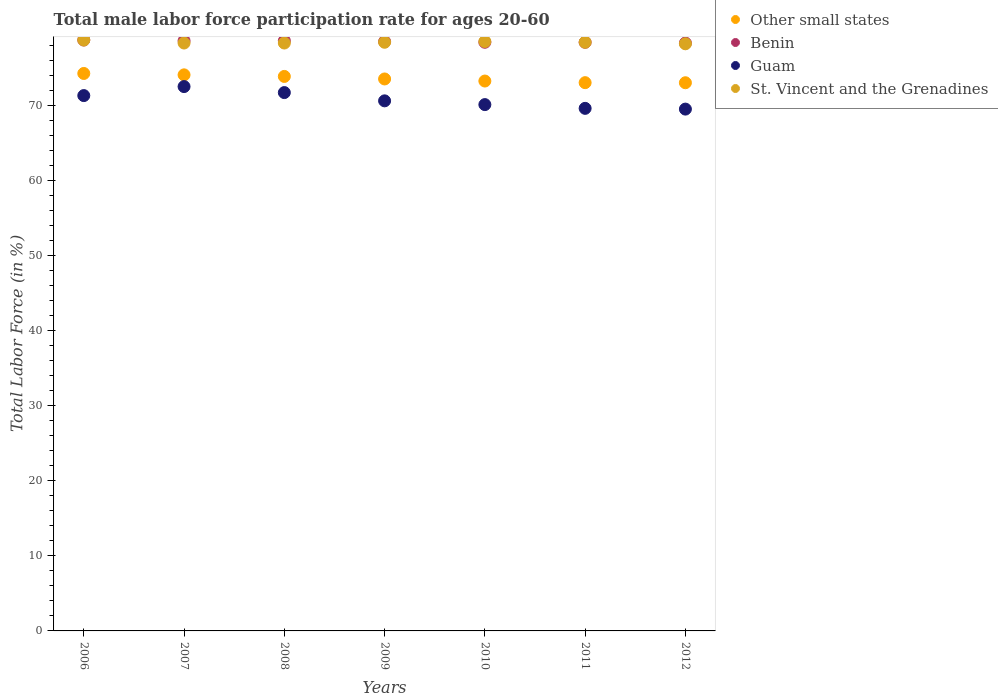How many different coloured dotlines are there?
Give a very brief answer. 4. What is the male labor force participation rate in Other small states in 2011?
Give a very brief answer. 73.02. Across all years, what is the maximum male labor force participation rate in St. Vincent and the Grenadines?
Make the answer very short. 78.7. Across all years, what is the minimum male labor force participation rate in Benin?
Make the answer very short. 78.3. In which year was the male labor force participation rate in St. Vincent and the Grenadines maximum?
Offer a very short reply. 2006. In which year was the male labor force participation rate in Other small states minimum?
Provide a succinct answer. 2012. What is the total male labor force participation rate in Benin in the graph?
Offer a terse response. 549.5. What is the difference between the male labor force participation rate in Other small states in 2008 and that in 2009?
Make the answer very short. 0.34. What is the difference between the male labor force participation rate in Benin in 2008 and the male labor force participation rate in St. Vincent and the Grenadines in 2009?
Make the answer very short. 0.2. What is the average male labor force participation rate in Benin per year?
Ensure brevity in your answer.  78.5. In the year 2008, what is the difference between the male labor force participation rate in Benin and male labor force participation rate in St. Vincent and the Grenadines?
Give a very brief answer. 0.3. In how many years, is the male labor force participation rate in Benin greater than 6 %?
Provide a succinct answer. 7. What is the ratio of the male labor force participation rate in Guam in 2006 to that in 2009?
Keep it short and to the point. 1.01. Is the difference between the male labor force participation rate in Benin in 2009 and 2010 greater than the difference between the male labor force participation rate in St. Vincent and the Grenadines in 2009 and 2010?
Your answer should be compact. Yes. What is the difference between the highest and the second highest male labor force participation rate in Benin?
Provide a succinct answer. 0.1. What is the difference between the highest and the lowest male labor force participation rate in Benin?
Provide a succinct answer. 0.4. In how many years, is the male labor force participation rate in Guam greater than the average male labor force participation rate in Guam taken over all years?
Your answer should be very brief. 3. Is it the case that in every year, the sum of the male labor force participation rate in Benin and male labor force participation rate in St. Vincent and the Grenadines  is greater than the sum of male labor force participation rate in Guam and male labor force participation rate in Other small states?
Your answer should be very brief. No. Is it the case that in every year, the sum of the male labor force participation rate in Other small states and male labor force participation rate in Benin  is greater than the male labor force participation rate in St. Vincent and the Grenadines?
Your response must be concise. Yes. Is the male labor force participation rate in Guam strictly greater than the male labor force participation rate in Benin over the years?
Your response must be concise. No. Is the male labor force participation rate in Benin strictly less than the male labor force participation rate in Other small states over the years?
Give a very brief answer. No. How many years are there in the graph?
Offer a terse response. 7. Does the graph contain grids?
Give a very brief answer. No. What is the title of the graph?
Your answer should be very brief. Total male labor force participation rate for ages 20-60. Does "Micronesia" appear as one of the legend labels in the graph?
Provide a short and direct response. No. What is the Total Labor Force (in %) of Other small states in 2006?
Make the answer very short. 74.25. What is the Total Labor Force (in %) in Benin in 2006?
Keep it short and to the point. 78.7. What is the Total Labor Force (in %) of Guam in 2006?
Provide a succinct answer. 71.3. What is the Total Labor Force (in %) in St. Vincent and the Grenadines in 2006?
Ensure brevity in your answer.  78.7. What is the Total Labor Force (in %) in Other small states in 2007?
Your answer should be very brief. 74.06. What is the Total Labor Force (in %) of Benin in 2007?
Offer a very short reply. 78.6. What is the Total Labor Force (in %) in Guam in 2007?
Give a very brief answer. 72.5. What is the Total Labor Force (in %) of St. Vincent and the Grenadines in 2007?
Ensure brevity in your answer.  78.3. What is the Total Labor Force (in %) of Other small states in 2008?
Offer a very short reply. 73.85. What is the Total Labor Force (in %) of Benin in 2008?
Ensure brevity in your answer.  78.6. What is the Total Labor Force (in %) of Guam in 2008?
Provide a succinct answer. 71.7. What is the Total Labor Force (in %) of St. Vincent and the Grenadines in 2008?
Provide a short and direct response. 78.3. What is the Total Labor Force (in %) of Other small states in 2009?
Keep it short and to the point. 73.51. What is the Total Labor Force (in %) of Benin in 2009?
Provide a succinct answer. 78.5. What is the Total Labor Force (in %) of Guam in 2009?
Ensure brevity in your answer.  70.6. What is the Total Labor Force (in %) of St. Vincent and the Grenadines in 2009?
Keep it short and to the point. 78.4. What is the Total Labor Force (in %) in Other small states in 2010?
Ensure brevity in your answer.  73.24. What is the Total Labor Force (in %) in Benin in 2010?
Provide a short and direct response. 78.4. What is the Total Labor Force (in %) in Guam in 2010?
Make the answer very short. 70.1. What is the Total Labor Force (in %) of St. Vincent and the Grenadines in 2010?
Offer a terse response. 78.5. What is the Total Labor Force (in %) in Other small states in 2011?
Give a very brief answer. 73.02. What is the Total Labor Force (in %) in Benin in 2011?
Keep it short and to the point. 78.4. What is the Total Labor Force (in %) of Guam in 2011?
Your answer should be very brief. 69.6. What is the Total Labor Force (in %) of St. Vincent and the Grenadines in 2011?
Offer a very short reply. 78.4. What is the Total Labor Force (in %) of Other small states in 2012?
Keep it short and to the point. 73.01. What is the Total Labor Force (in %) of Benin in 2012?
Keep it short and to the point. 78.3. What is the Total Labor Force (in %) of Guam in 2012?
Make the answer very short. 69.5. What is the Total Labor Force (in %) in St. Vincent and the Grenadines in 2012?
Keep it short and to the point. 78.2. Across all years, what is the maximum Total Labor Force (in %) in Other small states?
Provide a short and direct response. 74.25. Across all years, what is the maximum Total Labor Force (in %) in Benin?
Keep it short and to the point. 78.7. Across all years, what is the maximum Total Labor Force (in %) in Guam?
Keep it short and to the point. 72.5. Across all years, what is the maximum Total Labor Force (in %) in St. Vincent and the Grenadines?
Make the answer very short. 78.7. Across all years, what is the minimum Total Labor Force (in %) of Other small states?
Offer a very short reply. 73.01. Across all years, what is the minimum Total Labor Force (in %) of Benin?
Your answer should be very brief. 78.3. Across all years, what is the minimum Total Labor Force (in %) in Guam?
Keep it short and to the point. 69.5. Across all years, what is the minimum Total Labor Force (in %) in St. Vincent and the Grenadines?
Your response must be concise. 78.2. What is the total Total Labor Force (in %) in Other small states in the graph?
Ensure brevity in your answer.  514.95. What is the total Total Labor Force (in %) of Benin in the graph?
Offer a very short reply. 549.5. What is the total Total Labor Force (in %) in Guam in the graph?
Ensure brevity in your answer.  495.3. What is the total Total Labor Force (in %) in St. Vincent and the Grenadines in the graph?
Provide a short and direct response. 548.8. What is the difference between the Total Labor Force (in %) in Other small states in 2006 and that in 2007?
Offer a very short reply. 0.19. What is the difference between the Total Labor Force (in %) of Benin in 2006 and that in 2007?
Offer a terse response. 0.1. What is the difference between the Total Labor Force (in %) in Other small states in 2006 and that in 2008?
Make the answer very short. 0.4. What is the difference between the Total Labor Force (in %) in Benin in 2006 and that in 2008?
Offer a very short reply. 0.1. What is the difference between the Total Labor Force (in %) of Guam in 2006 and that in 2008?
Your answer should be very brief. -0.4. What is the difference between the Total Labor Force (in %) of Other small states in 2006 and that in 2009?
Your answer should be very brief. 0.73. What is the difference between the Total Labor Force (in %) in Benin in 2006 and that in 2009?
Your answer should be compact. 0.2. What is the difference between the Total Labor Force (in %) in Guam in 2006 and that in 2009?
Provide a succinct answer. 0.7. What is the difference between the Total Labor Force (in %) in St. Vincent and the Grenadines in 2006 and that in 2009?
Offer a very short reply. 0.3. What is the difference between the Total Labor Force (in %) in Other small states in 2006 and that in 2010?
Your answer should be very brief. 1.01. What is the difference between the Total Labor Force (in %) in St. Vincent and the Grenadines in 2006 and that in 2010?
Keep it short and to the point. 0.2. What is the difference between the Total Labor Force (in %) in Other small states in 2006 and that in 2011?
Give a very brief answer. 1.23. What is the difference between the Total Labor Force (in %) of St. Vincent and the Grenadines in 2006 and that in 2011?
Offer a very short reply. 0.3. What is the difference between the Total Labor Force (in %) in Other small states in 2006 and that in 2012?
Offer a very short reply. 1.24. What is the difference between the Total Labor Force (in %) of Benin in 2006 and that in 2012?
Provide a short and direct response. 0.4. What is the difference between the Total Labor Force (in %) of Other small states in 2007 and that in 2008?
Your response must be concise. 0.21. What is the difference between the Total Labor Force (in %) of Benin in 2007 and that in 2008?
Ensure brevity in your answer.  0. What is the difference between the Total Labor Force (in %) of Other small states in 2007 and that in 2009?
Ensure brevity in your answer.  0.55. What is the difference between the Total Labor Force (in %) of Guam in 2007 and that in 2009?
Keep it short and to the point. 1.9. What is the difference between the Total Labor Force (in %) of St. Vincent and the Grenadines in 2007 and that in 2009?
Offer a terse response. -0.1. What is the difference between the Total Labor Force (in %) of Other small states in 2007 and that in 2010?
Offer a terse response. 0.82. What is the difference between the Total Labor Force (in %) of Benin in 2007 and that in 2010?
Provide a succinct answer. 0.2. What is the difference between the Total Labor Force (in %) of St. Vincent and the Grenadines in 2007 and that in 2010?
Keep it short and to the point. -0.2. What is the difference between the Total Labor Force (in %) of Other small states in 2007 and that in 2011?
Ensure brevity in your answer.  1.04. What is the difference between the Total Labor Force (in %) in Benin in 2007 and that in 2011?
Offer a very short reply. 0.2. What is the difference between the Total Labor Force (in %) in Other small states in 2007 and that in 2012?
Offer a very short reply. 1.05. What is the difference between the Total Labor Force (in %) in Benin in 2007 and that in 2012?
Your answer should be compact. 0.3. What is the difference between the Total Labor Force (in %) in Guam in 2007 and that in 2012?
Give a very brief answer. 3. What is the difference between the Total Labor Force (in %) of St. Vincent and the Grenadines in 2007 and that in 2012?
Provide a succinct answer. 0.1. What is the difference between the Total Labor Force (in %) of Other small states in 2008 and that in 2009?
Provide a succinct answer. 0.34. What is the difference between the Total Labor Force (in %) of Benin in 2008 and that in 2009?
Your answer should be very brief. 0.1. What is the difference between the Total Labor Force (in %) in Other small states in 2008 and that in 2010?
Provide a succinct answer. 0.61. What is the difference between the Total Labor Force (in %) of Benin in 2008 and that in 2010?
Your response must be concise. 0.2. What is the difference between the Total Labor Force (in %) of Other small states in 2008 and that in 2011?
Your answer should be compact. 0.83. What is the difference between the Total Labor Force (in %) of Guam in 2008 and that in 2011?
Keep it short and to the point. 2.1. What is the difference between the Total Labor Force (in %) in Other small states in 2008 and that in 2012?
Your answer should be very brief. 0.84. What is the difference between the Total Labor Force (in %) of Benin in 2008 and that in 2012?
Offer a terse response. 0.3. What is the difference between the Total Labor Force (in %) of St. Vincent and the Grenadines in 2008 and that in 2012?
Your response must be concise. 0.1. What is the difference between the Total Labor Force (in %) in Other small states in 2009 and that in 2010?
Your answer should be compact. 0.28. What is the difference between the Total Labor Force (in %) in Benin in 2009 and that in 2010?
Offer a terse response. 0.1. What is the difference between the Total Labor Force (in %) in Guam in 2009 and that in 2010?
Offer a terse response. 0.5. What is the difference between the Total Labor Force (in %) of St. Vincent and the Grenadines in 2009 and that in 2010?
Ensure brevity in your answer.  -0.1. What is the difference between the Total Labor Force (in %) in Other small states in 2009 and that in 2011?
Provide a short and direct response. 0.49. What is the difference between the Total Labor Force (in %) of Benin in 2009 and that in 2011?
Your response must be concise. 0.1. What is the difference between the Total Labor Force (in %) in Guam in 2009 and that in 2011?
Make the answer very short. 1. What is the difference between the Total Labor Force (in %) of Other small states in 2009 and that in 2012?
Make the answer very short. 0.5. What is the difference between the Total Labor Force (in %) of Guam in 2009 and that in 2012?
Offer a terse response. 1.1. What is the difference between the Total Labor Force (in %) in St. Vincent and the Grenadines in 2009 and that in 2012?
Your response must be concise. 0.2. What is the difference between the Total Labor Force (in %) in Other small states in 2010 and that in 2011?
Make the answer very short. 0.22. What is the difference between the Total Labor Force (in %) of Benin in 2010 and that in 2011?
Offer a very short reply. 0. What is the difference between the Total Labor Force (in %) of Guam in 2010 and that in 2011?
Provide a succinct answer. 0.5. What is the difference between the Total Labor Force (in %) in St. Vincent and the Grenadines in 2010 and that in 2011?
Provide a short and direct response. 0.1. What is the difference between the Total Labor Force (in %) of Other small states in 2010 and that in 2012?
Ensure brevity in your answer.  0.23. What is the difference between the Total Labor Force (in %) in Guam in 2010 and that in 2012?
Your answer should be very brief. 0.6. What is the difference between the Total Labor Force (in %) of Other small states in 2011 and that in 2012?
Ensure brevity in your answer.  0.01. What is the difference between the Total Labor Force (in %) in Benin in 2011 and that in 2012?
Offer a very short reply. 0.1. What is the difference between the Total Labor Force (in %) of Other small states in 2006 and the Total Labor Force (in %) of Benin in 2007?
Your answer should be very brief. -4.35. What is the difference between the Total Labor Force (in %) in Other small states in 2006 and the Total Labor Force (in %) in Guam in 2007?
Give a very brief answer. 1.75. What is the difference between the Total Labor Force (in %) of Other small states in 2006 and the Total Labor Force (in %) of St. Vincent and the Grenadines in 2007?
Provide a succinct answer. -4.05. What is the difference between the Total Labor Force (in %) of Guam in 2006 and the Total Labor Force (in %) of St. Vincent and the Grenadines in 2007?
Offer a terse response. -7. What is the difference between the Total Labor Force (in %) of Other small states in 2006 and the Total Labor Force (in %) of Benin in 2008?
Ensure brevity in your answer.  -4.35. What is the difference between the Total Labor Force (in %) in Other small states in 2006 and the Total Labor Force (in %) in Guam in 2008?
Your answer should be compact. 2.55. What is the difference between the Total Labor Force (in %) of Other small states in 2006 and the Total Labor Force (in %) of St. Vincent and the Grenadines in 2008?
Provide a short and direct response. -4.05. What is the difference between the Total Labor Force (in %) of Benin in 2006 and the Total Labor Force (in %) of St. Vincent and the Grenadines in 2008?
Your answer should be very brief. 0.4. What is the difference between the Total Labor Force (in %) of Guam in 2006 and the Total Labor Force (in %) of St. Vincent and the Grenadines in 2008?
Offer a very short reply. -7. What is the difference between the Total Labor Force (in %) in Other small states in 2006 and the Total Labor Force (in %) in Benin in 2009?
Offer a very short reply. -4.25. What is the difference between the Total Labor Force (in %) of Other small states in 2006 and the Total Labor Force (in %) of Guam in 2009?
Ensure brevity in your answer.  3.65. What is the difference between the Total Labor Force (in %) in Other small states in 2006 and the Total Labor Force (in %) in St. Vincent and the Grenadines in 2009?
Your answer should be compact. -4.15. What is the difference between the Total Labor Force (in %) in Benin in 2006 and the Total Labor Force (in %) in St. Vincent and the Grenadines in 2009?
Offer a very short reply. 0.3. What is the difference between the Total Labor Force (in %) of Guam in 2006 and the Total Labor Force (in %) of St. Vincent and the Grenadines in 2009?
Provide a succinct answer. -7.1. What is the difference between the Total Labor Force (in %) of Other small states in 2006 and the Total Labor Force (in %) of Benin in 2010?
Keep it short and to the point. -4.15. What is the difference between the Total Labor Force (in %) of Other small states in 2006 and the Total Labor Force (in %) of Guam in 2010?
Provide a succinct answer. 4.15. What is the difference between the Total Labor Force (in %) in Other small states in 2006 and the Total Labor Force (in %) in St. Vincent and the Grenadines in 2010?
Your answer should be very brief. -4.25. What is the difference between the Total Labor Force (in %) of Benin in 2006 and the Total Labor Force (in %) of St. Vincent and the Grenadines in 2010?
Your answer should be compact. 0.2. What is the difference between the Total Labor Force (in %) of Guam in 2006 and the Total Labor Force (in %) of St. Vincent and the Grenadines in 2010?
Give a very brief answer. -7.2. What is the difference between the Total Labor Force (in %) in Other small states in 2006 and the Total Labor Force (in %) in Benin in 2011?
Your answer should be compact. -4.15. What is the difference between the Total Labor Force (in %) of Other small states in 2006 and the Total Labor Force (in %) of Guam in 2011?
Keep it short and to the point. 4.65. What is the difference between the Total Labor Force (in %) of Other small states in 2006 and the Total Labor Force (in %) of St. Vincent and the Grenadines in 2011?
Your answer should be compact. -4.15. What is the difference between the Total Labor Force (in %) of Benin in 2006 and the Total Labor Force (in %) of Guam in 2011?
Offer a very short reply. 9.1. What is the difference between the Total Labor Force (in %) in Benin in 2006 and the Total Labor Force (in %) in St. Vincent and the Grenadines in 2011?
Offer a very short reply. 0.3. What is the difference between the Total Labor Force (in %) in Other small states in 2006 and the Total Labor Force (in %) in Benin in 2012?
Offer a terse response. -4.05. What is the difference between the Total Labor Force (in %) of Other small states in 2006 and the Total Labor Force (in %) of Guam in 2012?
Give a very brief answer. 4.75. What is the difference between the Total Labor Force (in %) of Other small states in 2006 and the Total Labor Force (in %) of St. Vincent and the Grenadines in 2012?
Keep it short and to the point. -3.95. What is the difference between the Total Labor Force (in %) in Benin in 2006 and the Total Labor Force (in %) in St. Vincent and the Grenadines in 2012?
Provide a short and direct response. 0.5. What is the difference between the Total Labor Force (in %) in Other small states in 2007 and the Total Labor Force (in %) in Benin in 2008?
Provide a short and direct response. -4.54. What is the difference between the Total Labor Force (in %) in Other small states in 2007 and the Total Labor Force (in %) in Guam in 2008?
Keep it short and to the point. 2.36. What is the difference between the Total Labor Force (in %) of Other small states in 2007 and the Total Labor Force (in %) of St. Vincent and the Grenadines in 2008?
Give a very brief answer. -4.24. What is the difference between the Total Labor Force (in %) of Guam in 2007 and the Total Labor Force (in %) of St. Vincent and the Grenadines in 2008?
Make the answer very short. -5.8. What is the difference between the Total Labor Force (in %) of Other small states in 2007 and the Total Labor Force (in %) of Benin in 2009?
Ensure brevity in your answer.  -4.44. What is the difference between the Total Labor Force (in %) of Other small states in 2007 and the Total Labor Force (in %) of Guam in 2009?
Make the answer very short. 3.46. What is the difference between the Total Labor Force (in %) in Other small states in 2007 and the Total Labor Force (in %) in St. Vincent and the Grenadines in 2009?
Keep it short and to the point. -4.34. What is the difference between the Total Labor Force (in %) of Benin in 2007 and the Total Labor Force (in %) of Guam in 2009?
Make the answer very short. 8. What is the difference between the Total Labor Force (in %) in Benin in 2007 and the Total Labor Force (in %) in St. Vincent and the Grenadines in 2009?
Your answer should be compact. 0.2. What is the difference between the Total Labor Force (in %) of Guam in 2007 and the Total Labor Force (in %) of St. Vincent and the Grenadines in 2009?
Make the answer very short. -5.9. What is the difference between the Total Labor Force (in %) in Other small states in 2007 and the Total Labor Force (in %) in Benin in 2010?
Your answer should be compact. -4.34. What is the difference between the Total Labor Force (in %) in Other small states in 2007 and the Total Labor Force (in %) in Guam in 2010?
Give a very brief answer. 3.96. What is the difference between the Total Labor Force (in %) in Other small states in 2007 and the Total Labor Force (in %) in St. Vincent and the Grenadines in 2010?
Your response must be concise. -4.44. What is the difference between the Total Labor Force (in %) in Benin in 2007 and the Total Labor Force (in %) in Guam in 2010?
Give a very brief answer. 8.5. What is the difference between the Total Labor Force (in %) of Other small states in 2007 and the Total Labor Force (in %) of Benin in 2011?
Ensure brevity in your answer.  -4.34. What is the difference between the Total Labor Force (in %) of Other small states in 2007 and the Total Labor Force (in %) of Guam in 2011?
Give a very brief answer. 4.46. What is the difference between the Total Labor Force (in %) in Other small states in 2007 and the Total Labor Force (in %) in St. Vincent and the Grenadines in 2011?
Make the answer very short. -4.34. What is the difference between the Total Labor Force (in %) of Other small states in 2007 and the Total Labor Force (in %) of Benin in 2012?
Make the answer very short. -4.24. What is the difference between the Total Labor Force (in %) of Other small states in 2007 and the Total Labor Force (in %) of Guam in 2012?
Give a very brief answer. 4.56. What is the difference between the Total Labor Force (in %) in Other small states in 2007 and the Total Labor Force (in %) in St. Vincent and the Grenadines in 2012?
Keep it short and to the point. -4.14. What is the difference between the Total Labor Force (in %) of Benin in 2007 and the Total Labor Force (in %) of Guam in 2012?
Your answer should be very brief. 9.1. What is the difference between the Total Labor Force (in %) of Guam in 2007 and the Total Labor Force (in %) of St. Vincent and the Grenadines in 2012?
Keep it short and to the point. -5.7. What is the difference between the Total Labor Force (in %) of Other small states in 2008 and the Total Labor Force (in %) of Benin in 2009?
Provide a short and direct response. -4.65. What is the difference between the Total Labor Force (in %) in Other small states in 2008 and the Total Labor Force (in %) in Guam in 2009?
Provide a short and direct response. 3.25. What is the difference between the Total Labor Force (in %) in Other small states in 2008 and the Total Labor Force (in %) in St. Vincent and the Grenadines in 2009?
Offer a very short reply. -4.55. What is the difference between the Total Labor Force (in %) in Benin in 2008 and the Total Labor Force (in %) in Guam in 2009?
Your answer should be very brief. 8. What is the difference between the Total Labor Force (in %) of Benin in 2008 and the Total Labor Force (in %) of St. Vincent and the Grenadines in 2009?
Provide a short and direct response. 0.2. What is the difference between the Total Labor Force (in %) of Other small states in 2008 and the Total Labor Force (in %) of Benin in 2010?
Your response must be concise. -4.55. What is the difference between the Total Labor Force (in %) of Other small states in 2008 and the Total Labor Force (in %) of Guam in 2010?
Provide a succinct answer. 3.75. What is the difference between the Total Labor Force (in %) of Other small states in 2008 and the Total Labor Force (in %) of St. Vincent and the Grenadines in 2010?
Give a very brief answer. -4.65. What is the difference between the Total Labor Force (in %) of Benin in 2008 and the Total Labor Force (in %) of St. Vincent and the Grenadines in 2010?
Ensure brevity in your answer.  0.1. What is the difference between the Total Labor Force (in %) in Guam in 2008 and the Total Labor Force (in %) in St. Vincent and the Grenadines in 2010?
Your answer should be very brief. -6.8. What is the difference between the Total Labor Force (in %) of Other small states in 2008 and the Total Labor Force (in %) of Benin in 2011?
Make the answer very short. -4.55. What is the difference between the Total Labor Force (in %) in Other small states in 2008 and the Total Labor Force (in %) in Guam in 2011?
Your answer should be compact. 4.25. What is the difference between the Total Labor Force (in %) in Other small states in 2008 and the Total Labor Force (in %) in St. Vincent and the Grenadines in 2011?
Provide a short and direct response. -4.55. What is the difference between the Total Labor Force (in %) in Benin in 2008 and the Total Labor Force (in %) in St. Vincent and the Grenadines in 2011?
Your answer should be compact. 0.2. What is the difference between the Total Labor Force (in %) in Guam in 2008 and the Total Labor Force (in %) in St. Vincent and the Grenadines in 2011?
Provide a short and direct response. -6.7. What is the difference between the Total Labor Force (in %) in Other small states in 2008 and the Total Labor Force (in %) in Benin in 2012?
Offer a terse response. -4.45. What is the difference between the Total Labor Force (in %) of Other small states in 2008 and the Total Labor Force (in %) of Guam in 2012?
Your answer should be very brief. 4.35. What is the difference between the Total Labor Force (in %) of Other small states in 2008 and the Total Labor Force (in %) of St. Vincent and the Grenadines in 2012?
Keep it short and to the point. -4.35. What is the difference between the Total Labor Force (in %) in Benin in 2008 and the Total Labor Force (in %) in Guam in 2012?
Your response must be concise. 9.1. What is the difference between the Total Labor Force (in %) of Benin in 2008 and the Total Labor Force (in %) of St. Vincent and the Grenadines in 2012?
Ensure brevity in your answer.  0.4. What is the difference between the Total Labor Force (in %) of Other small states in 2009 and the Total Labor Force (in %) of Benin in 2010?
Provide a short and direct response. -4.89. What is the difference between the Total Labor Force (in %) of Other small states in 2009 and the Total Labor Force (in %) of Guam in 2010?
Give a very brief answer. 3.41. What is the difference between the Total Labor Force (in %) of Other small states in 2009 and the Total Labor Force (in %) of St. Vincent and the Grenadines in 2010?
Give a very brief answer. -4.99. What is the difference between the Total Labor Force (in %) of Other small states in 2009 and the Total Labor Force (in %) of Benin in 2011?
Give a very brief answer. -4.89. What is the difference between the Total Labor Force (in %) in Other small states in 2009 and the Total Labor Force (in %) in Guam in 2011?
Your answer should be very brief. 3.91. What is the difference between the Total Labor Force (in %) in Other small states in 2009 and the Total Labor Force (in %) in St. Vincent and the Grenadines in 2011?
Your response must be concise. -4.89. What is the difference between the Total Labor Force (in %) of Guam in 2009 and the Total Labor Force (in %) of St. Vincent and the Grenadines in 2011?
Your answer should be compact. -7.8. What is the difference between the Total Labor Force (in %) in Other small states in 2009 and the Total Labor Force (in %) in Benin in 2012?
Ensure brevity in your answer.  -4.79. What is the difference between the Total Labor Force (in %) in Other small states in 2009 and the Total Labor Force (in %) in Guam in 2012?
Give a very brief answer. 4.01. What is the difference between the Total Labor Force (in %) in Other small states in 2009 and the Total Labor Force (in %) in St. Vincent and the Grenadines in 2012?
Ensure brevity in your answer.  -4.69. What is the difference between the Total Labor Force (in %) in Benin in 2009 and the Total Labor Force (in %) in St. Vincent and the Grenadines in 2012?
Your response must be concise. 0.3. What is the difference between the Total Labor Force (in %) in Other small states in 2010 and the Total Labor Force (in %) in Benin in 2011?
Your answer should be very brief. -5.16. What is the difference between the Total Labor Force (in %) of Other small states in 2010 and the Total Labor Force (in %) of Guam in 2011?
Your response must be concise. 3.64. What is the difference between the Total Labor Force (in %) in Other small states in 2010 and the Total Labor Force (in %) in St. Vincent and the Grenadines in 2011?
Your response must be concise. -5.16. What is the difference between the Total Labor Force (in %) in Benin in 2010 and the Total Labor Force (in %) in Guam in 2011?
Ensure brevity in your answer.  8.8. What is the difference between the Total Labor Force (in %) in Benin in 2010 and the Total Labor Force (in %) in St. Vincent and the Grenadines in 2011?
Give a very brief answer. 0. What is the difference between the Total Labor Force (in %) of Guam in 2010 and the Total Labor Force (in %) of St. Vincent and the Grenadines in 2011?
Your response must be concise. -8.3. What is the difference between the Total Labor Force (in %) in Other small states in 2010 and the Total Labor Force (in %) in Benin in 2012?
Make the answer very short. -5.06. What is the difference between the Total Labor Force (in %) in Other small states in 2010 and the Total Labor Force (in %) in Guam in 2012?
Give a very brief answer. 3.74. What is the difference between the Total Labor Force (in %) of Other small states in 2010 and the Total Labor Force (in %) of St. Vincent and the Grenadines in 2012?
Keep it short and to the point. -4.96. What is the difference between the Total Labor Force (in %) in Benin in 2010 and the Total Labor Force (in %) in St. Vincent and the Grenadines in 2012?
Provide a succinct answer. 0.2. What is the difference between the Total Labor Force (in %) of Other small states in 2011 and the Total Labor Force (in %) of Benin in 2012?
Offer a terse response. -5.28. What is the difference between the Total Labor Force (in %) of Other small states in 2011 and the Total Labor Force (in %) of Guam in 2012?
Provide a succinct answer. 3.52. What is the difference between the Total Labor Force (in %) in Other small states in 2011 and the Total Labor Force (in %) in St. Vincent and the Grenadines in 2012?
Offer a terse response. -5.18. What is the difference between the Total Labor Force (in %) in Benin in 2011 and the Total Labor Force (in %) in Guam in 2012?
Give a very brief answer. 8.9. What is the difference between the Total Labor Force (in %) in Guam in 2011 and the Total Labor Force (in %) in St. Vincent and the Grenadines in 2012?
Keep it short and to the point. -8.6. What is the average Total Labor Force (in %) in Other small states per year?
Offer a terse response. 73.56. What is the average Total Labor Force (in %) of Benin per year?
Give a very brief answer. 78.5. What is the average Total Labor Force (in %) of Guam per year?
Your answer should be compact. 70.76. What is the average Total Labor Force (in %) in St. Vincent and the Grenadines per year?
Your response must be concise. 78.4. In the year 2006, what is the difference between the Total Labor Force (in %) of Other small states and Total Labor Force (in %) of Benin?
Provide a succinct answer. -4.45. In the year 2006, what is the difference between the Total Labor Force (in %) of Other small states and Total Labor Force (in %) of Guam?
Make the answer very short. 2.95. In the year 2006, what is the difference between the Total Labor Force (in %) of Other small states and Total Labor Force (in %) of St. Vincent and the Grenadines?
Keep it short and to the point. -4.45. In the year 2006, what is the difference between the Total Labor Force (in %) of Benin and Total Labor Force (in %) of St. Vincent and the Grenadines?
Give a very brief answer. 0. In the year 2006, what is the difference between the Total Labor Force (in %) of Guam and Total Labor Force (in %) of St. Vincent and the Grenadines?
Make the answer very short. -7.4. In the year 2007, what is the difference between the Total Labor Force (in %) of Other small states and Total Labor Force (in %) of Benin?
Provide a short and direct response. -4.54. In the year 2007, what is the difference between the Total Labor Force (in %) of Other small states and Total Labor Force (in %) of Guam?
Keep it short and to the point. 1.56. In the year 2007, what is the difference between the Total Labor Force (in %) in Other small states and Total Labor Force (in %) in St. Vincent and the Grenadines?
Give a very brief answer. -4.24. In the year 2007, what is the difference between the Total Labor Force (in %) in Benin and Total Labor Force (in %) in Guam?
Provide a short and direct response. 6.1. In the year 2007, what is the difference between the Total Labor Force (in %) in Benin and Total Labor Force (in %) in St. Vincent and the Grenadines?
Give a very brief answer. 0.3. In the year 2007, what is the difference between the Total Labor Force (in %) in Guam and Total Labor Force (in %) in St. Vincent and the Grenadines?
Ensure brevity in your answer.  -5.8. In the year 2008, what is the difference between the Total Labor Force (in %) of Other small states and Total Labor Force (in %) of Benin?
Ensure brevity in your answer.  -4.75. In the year 2008, what is the difference between the Total Labor Force (in %) in Other small states and Total Labor Force (in %) in Guam?
Your answer should be compact. 2.15. In the year 2008, what is the difference between the Total Labor Force (in %) of Other small states and Total Labor Force (in %) of St. Vincent and the Grenadines?
Your answer should be compact. -4.45. In the year 2008, what is the difference between the Total Labor Force (in %) in Benin and Total Labor Force (in %) in Guam?
Ensure brevity in your answer.  6.9. In the year 2009, what is the difference between the Total Labor Force (in %) in Other small states and Total Labor Force (in %) in Benin?
Ensure brevity in your answer.  -4.99. In the year 2009, what is the difference between the Total Labor Force (in %) in Other small states and Total Labor Force (in %) in Guam?
Keep it short and to the point. 2.91. In the year 2009, what is the difference between the Total Labor Force (in %) of Other small states and Total Labor Force (in %) of St. Vincent and the Grenadines?
Give a very brief answer. -4.89. In the year 2009, what is the difference between the Total Labor Force (in %) of Benin and Total Labor Force (in %) of Guam?
Your answer should be compact. 7.9. In the year 2010, what is the difference between the Total Labor Force (in %) of Other small states and Total Labor Force (in %) of Benin?
Your answer should be very brief. -5.16. In the year 2010, what is the difference between the Total Labor Force (in %) in Other small states and Total Labor Force (in %) in Guam?
Your answer should be very brief. 3.14. In the year 2010, what is the difference between the Total Labor Force (in %) of Other small states and Total Labor Force (in %) of St. Vincent and the Grenadines?
Your answer should be very brief. -5.26. In the year 2011, what is the difference between the Total Labor Force (in %) of Other small states and Total Labor Force (in %) of Benin?
Offer a very short reply. -5.38. In the year 2011, what is the difference between the Total Labor Force (in %) of Other small states and Total Labor Force (in %) of Guam?
Your answer should be very brief. 3.42. In the year 2011, what is the difference between the Total Labor Force (in %) of Other small states and Total Labor Force (in %) of St. Vincent and the Grenadines?
Your response must be concise. -5.38. In the year 2011, what is the difference between the Total Labor Force (in %) in Benin and Total Labor Force (in %) in Guam?
Offer a very short reply. 8.8. In the year 2011, what is the difference between the Total Labor Force (in %) in Guam and Total Labor Force (in %) in St. Vincent and the Grenadines?
Provide a short and direct response. -8.8. In the year 2012, what is the difference between the Total Labor Force (in %) of Other small states and Total Labor Force (in %) of Benin?
Ensure brevity in your answer.  -5.29. In the year 2012, what is the difference between the Total Labor Force (in %) in Other small states and Total Labor Force (in %) in Guam?
Provide a short and direct response. 3.51. In the year 2012, what is the difference between the Total Labor Force (in %) in Other small states and Total Labor Force (in %) in St. Vincent and the Grenadines?
Ensure brevity in your answer.  -5.19. In the year 2012, what is the difference between the Total Labor Force (in %) in Benin and Total Labor Force (in %) in St. Vincent and the Grenadines?
Offer a terse response. 0.1. In the year 2012, what is the difference between the Total Labor Force (in %) in Guam and Total Labor Force (in %) in St. Vincent and the Grenadines?
Offer a very short reply. -8.7. What is the ratio of the Total Labor Force (in %) in Other small states in 2006 to that in 2007?
Offer a terse response. 1. What is the ratio of the Total Labor Force (in %) in Guam in 2006 to that in 2007?
Offer a very short reply. 0.98. What is the ratio of the Total Labor Force (in %) of St. Vincent and the Grenadines in 2006 to that in 2007?
Offer a very short reply. 1.01. What is the ratio of the Total Labor Force (in %) of Other small states in 2006 to that in 2008?
Keep it short and to the point. 1.01. What is the ratio of the Total Labor Force (in %) of St. Vincent and the Grenadines in 2006 to that in 2008?
Your answer should be compact. 1.01. What is the ratio of the Total Labor Force (in %) of Guam in 2006 to that in 2009?
Provide a succinct answer. 1.01. What is the ratio of the Total Labor Force (in %) in St. Vincent and the Grenadines in 2006 to that in 2009?
Your answer should be compact. 1. What is the ratio of the Total Labor Force (in %) in Other small states in 2006 to that in 2010?
Make the answer very short. 1.01. What is the ratio of the Total Labor Force (in %) of Guam in 2006 to that in 2010?
Make the answer very short. 1.02. What is the ratio of the Total Labor Force (in %) of St. Vincent and the Grenadines in 2006 to that in 2010?
Give a very brief answer. 1. What is the ratio of the Total Labor Force (in %) of Other small states in 2006 to that in 2011?
Provide a short and direct response. 1.02. What is the ratio of the Total Labor Force (in %) of Guam in 2006 to that in 2011?
Give a very brief answer. 1.02. What is the ratio of the Total Labor Force (in %) in Other small states in 2006 to that in 2012?
Provide a succinct answer. 1.02. What is the ratio of the Total Labor Force (in %) in Guam in 2006 to that in 2012?
Your answer should be very brief. 1.03. What is the ratio of the Total Labor Force (in %) of St. Vincent and the Grenadines in 2006 to that in 2012?
Your answer should be compact. 1.01. What is the ratio of the Total Labor Force (in %) in Benin in 2007 to that in 2008?
Give a very brief answer. 1. What is the ratio of the Total Labor Force (in %) of Guam in 2007 to that in 2008?
Keep it short and to the point. 1.01. What is the ratio of the Total Labor Force (in %) of St. Vincent and the Grenadines in 2007 to that in 2008?
Give a very brief answer. 1. What is the ratio of the Total Labor Force (in %) of Other small states in 2007 to that in 2009?
Offer a very short reply. 1.01. What is the ratio of the Total Labor Force (in %) in Benin in 2007 to that in 2009?
Keep it short and to the point. 1. What is the ratio of the Total Labor Force (in %) of Guam in 2007 to that in 2009?
Ensure brevity in your answer.  1.03. What is the ratio of the Total Labor Force (in %) in Other small states in 2007 to that in 2010?
Provide a short and direct response. 1.01. What is the ratio of the Total Labor Force (in %) in Benin in 2007 to that in 2010?
Make the answer very short. 1. What is the ratio of the Total Labor Force (in %) in Guam in 2007 to that in 2010?
Your answer should be compact. 1.03. What is the ratio of the Total Labor Force (in %) in Other small states in 2007 to that in 2011?
Your answer should be compact. 1.01. What is the ratio of the Total Labor Force (in %) in Benin in 2007 to that in 2011?
Give a very brief answer. 1. What is the ratio of the Total Labor Force (in %) of Guam in 2007 to that in 2011?
Give a very brief answer. 1.04. What is the ratio of the Total Labor Force (in %) in Other small states in 2007 to that in 2012?
Offer a very short reply. 1.01. What is the ratio of the Total Labor Force (in %) in Benin in 2007 to that in 2012?
Your answer should be very brief. 1. What is the ratio of the Total Labor Force (in %) in Guam in 2007 to that in 2012?
Provide a succinct answer. 1.04. What is the ratio of the Total Labor Force (in %) of St. Vincent and the Grenadines in 2007 to that in 2012?
Offer a terse response. 1. What is the ratio of the Total Labor Force (in %) in Other small states in 2008 to that in 2009?
Your answer should be compact. 1. What is the ratio of the Total Labor Force (in %) of Guam in 2008 to that in 2009?
Provide a short and direct response. 1.02. What is the ratio of the Total Labor Force (in %) in St. Vincent and the Grenadines in 2008 to that in 2009?
Ensure brevity in your answer.  1. What is the ratio of the Total Labor Force (in %) of Other small states in 2008 to that in 2010?
Give a very brief answer. 1.01. What is the ratio of the Total Labor Force (in %) of Benin in 2008 to that in 2010?
Make the answer very short. 1. What is the ratio of the Total Labor Force (in %) of Guam in 2008 to that in 2010?
Your answer should be compact. 1.02. What is the ratio of the Total Labor Force (in %) in Other small states in 2008 to that in 2011?
Offer a terse response. 1.01. What is the ratio of the Total Labor Force (in %) of Benin in 2008 to that in 2011?
Provide a succinct answer. 1. What is the ratio of the Total Labor Force (in %) of Guam in 2008 to that in 2011?
Give a very brief answer. 1.03. What is the ratio of the Total Labor Force (in %) of Other small states in 2008 to that in 2012?
Offer a terse response. 1.01. What is the ratio of the Total Labor Force (in %) of Benin in 2008 to that in 2012?
Keep it short and to the point. 1. What is the ratio of the Total Labor Force (in %) of Guam in 2008 to that in 2012?
Provide a short and direct response. 1.03. What is the ratio of the Total Labor Force (in %) of Other small states in 2009 to that in 2010?
Provide a succinct answer. 1. What is the ratio of the Total Labor Force (in %) of Guam in 2009 to that in 2010?
Make the answer very short. 1.01. What is the ratio of the Total Labor Force (in %) of Other small states in 2009 to that in 2011?
Ensure brevity in your answer.  1.01. What is the ratio of the Total Labor Force (in %) in Guam in 2009 to that in 2011?
Make the answer very short. 1.01. What is the ratio of the Total Labor Force (in %) of Guam in 2009 to that in 2012?
Ensure brevity in your answer.  1.02. What is the ratio of the Total Labor Force (in %) of Guam in 2010 to that in 2011?
Keep it short and to the point. 1.01. What is the ratio of the Total Labor Force (in %) of St. Vincent and the Grenadines in 2010 to that in 2011?
Offer a terse response. 1. What is the ratio of the Total Labor Force (in %) of Other small states in 2010 to that in 2012?
Offer a very short reply. 1. What is the ratio of the Total Labor Force (in %) of Benin in 2010 to that in 2012?
Keep it short and to the point. 1. What is the ratio of the Total Labor Force (in %) in Guam in 2010 to that in 2012?
Offer a terse response. 1.01. What is the difference between the highest and the second highest Total Labor Force (in %) in Other small states?
Ensure brevity in your answer.  0.19. What is the difference between the highest and the second highest Total Labor Force (in %) in Benin?
Offer a terse response. 0.1. What is the difference between the highest and the second highest Total Labor Force (in %) in St. Vincent and the Grenadines?
Provide a succinct answer. 0.2. What is the difference between the highest and the lowest Total Labor Force (in %) of Other small states?
Give a very brief answer. 1.24. What is the difference between the highest and the lowest Total Labor Force (in %) of Benin?
Offer a terse response. 0.4. What is the difference between the highest and the lowest Total Labor Force (in %) in Guam?
Provide a succinct answer. 3. 